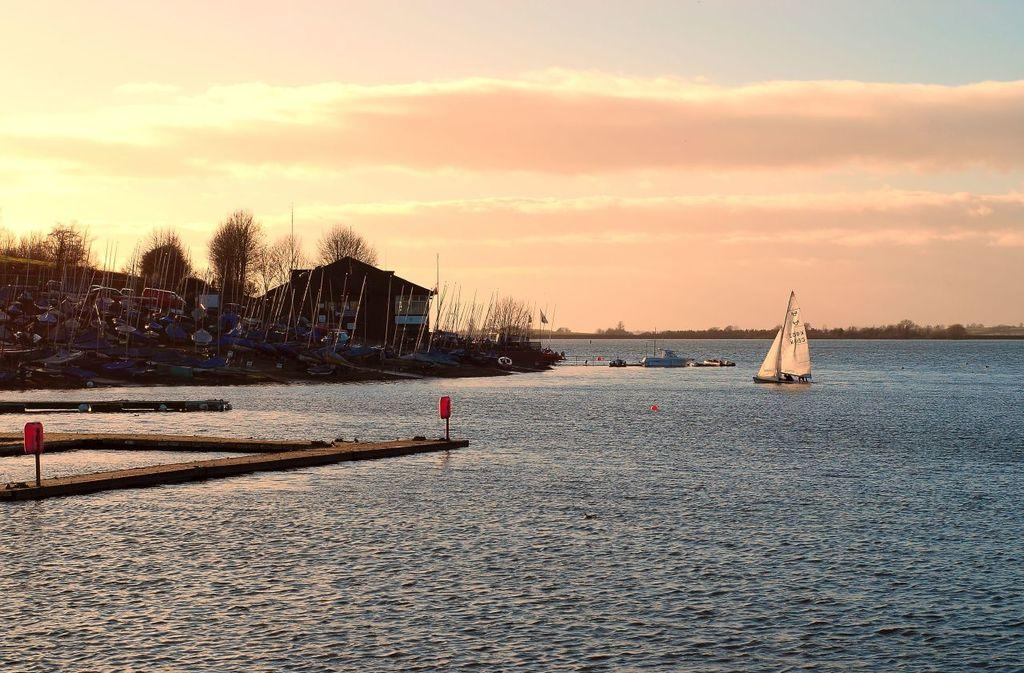What can be seen in the foreground of the image? In the foreground of the image, there are boards, a fence, and a boat in the water. What is visible in the background of the image? In the background of the image, there are houses, boats, trees, and the sky. What might be the location of the image? The image might be taken in the ocean, given the presence of water and boats. How many spiders can be seen crawling on the fence in the image? There are no spiders visible in the image; it features a fence, boards, and a boat in the water. What type of brush can be seen in the image? There is no brush present in the image. 